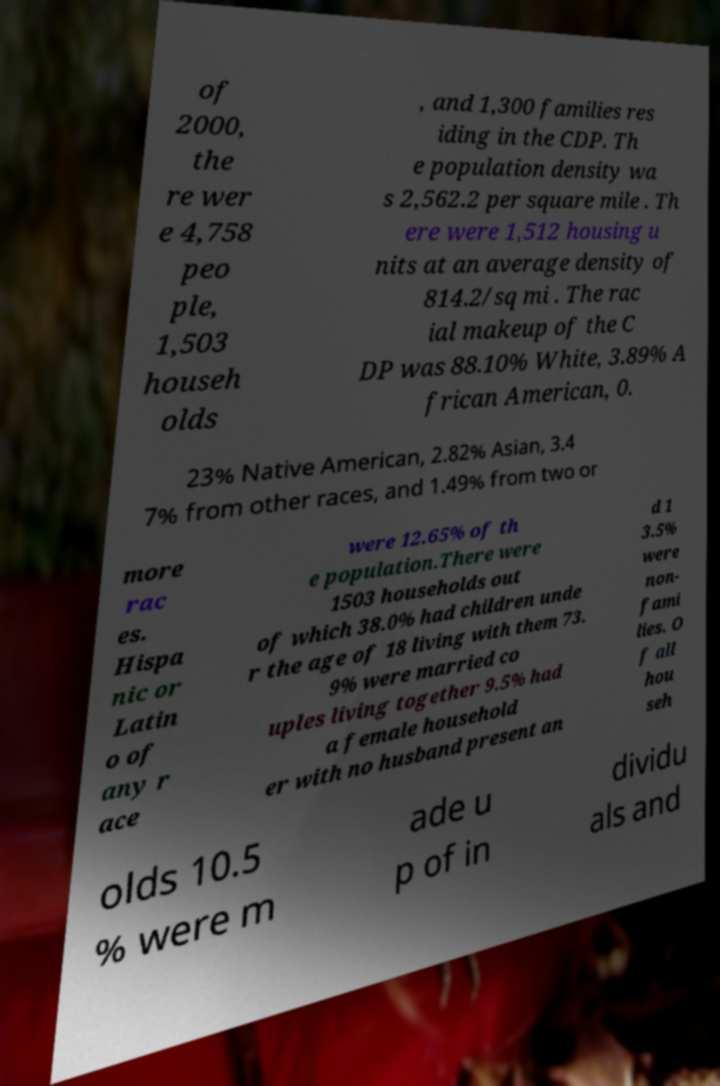Could you assist in decoding the text presented in this image and type it out clearly? of 2000, the re wer e 4,758 peo ple, 1,503 househ olds , and 1,300 families res iding in the CDP. Th e population density wa s 2,562.2 per square mile . Th ere were 1,512 housing u nits at an average density of 814.2/sq mi . The rac ial makeup of the C DP was 88.10% White, 3.89% A frican American, 0. 23% Native American, 2.82% Asian, 3.4 7% from other races, and 1.49% from two or more rac es. Hispa nic or Latin o of any r ace were 12.65% of th e population.There were 1503 households out of which 38.0% had children unde r the age of 18 living with them 73. 9% were married co uples living together 9.5% had a female household er with no husband present an d 1 3.5% were non- fami lies. O f all hou seh olds 10.5 % were m ade u p of in dividu als and 